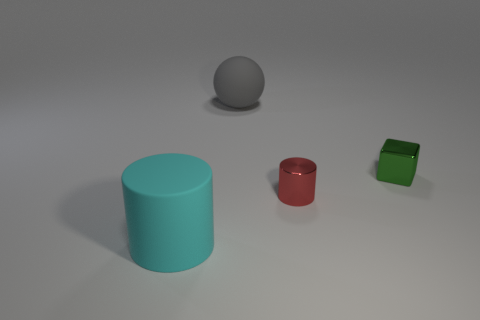Add 4 large blue objects. How many objects exist? 8 Subtract all blocks. How many objects are left? 3 Subtract all metal things. Subtract all gray blocks. How many objects are left? 2 Add 2 small red metal cylinders. How many small red metal cylinders are left? 3 Add 2 large spheres. How many large spheres exist? 3 Subtract 0 cyan spheres. How many objects are left? 4 